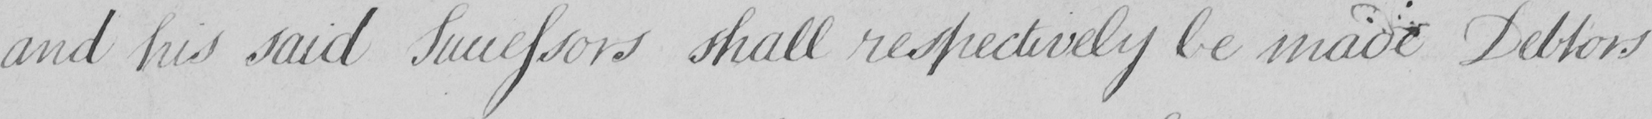Can you read and transcribe this handwriting? and his said Successors shall respectively be made Debtors 